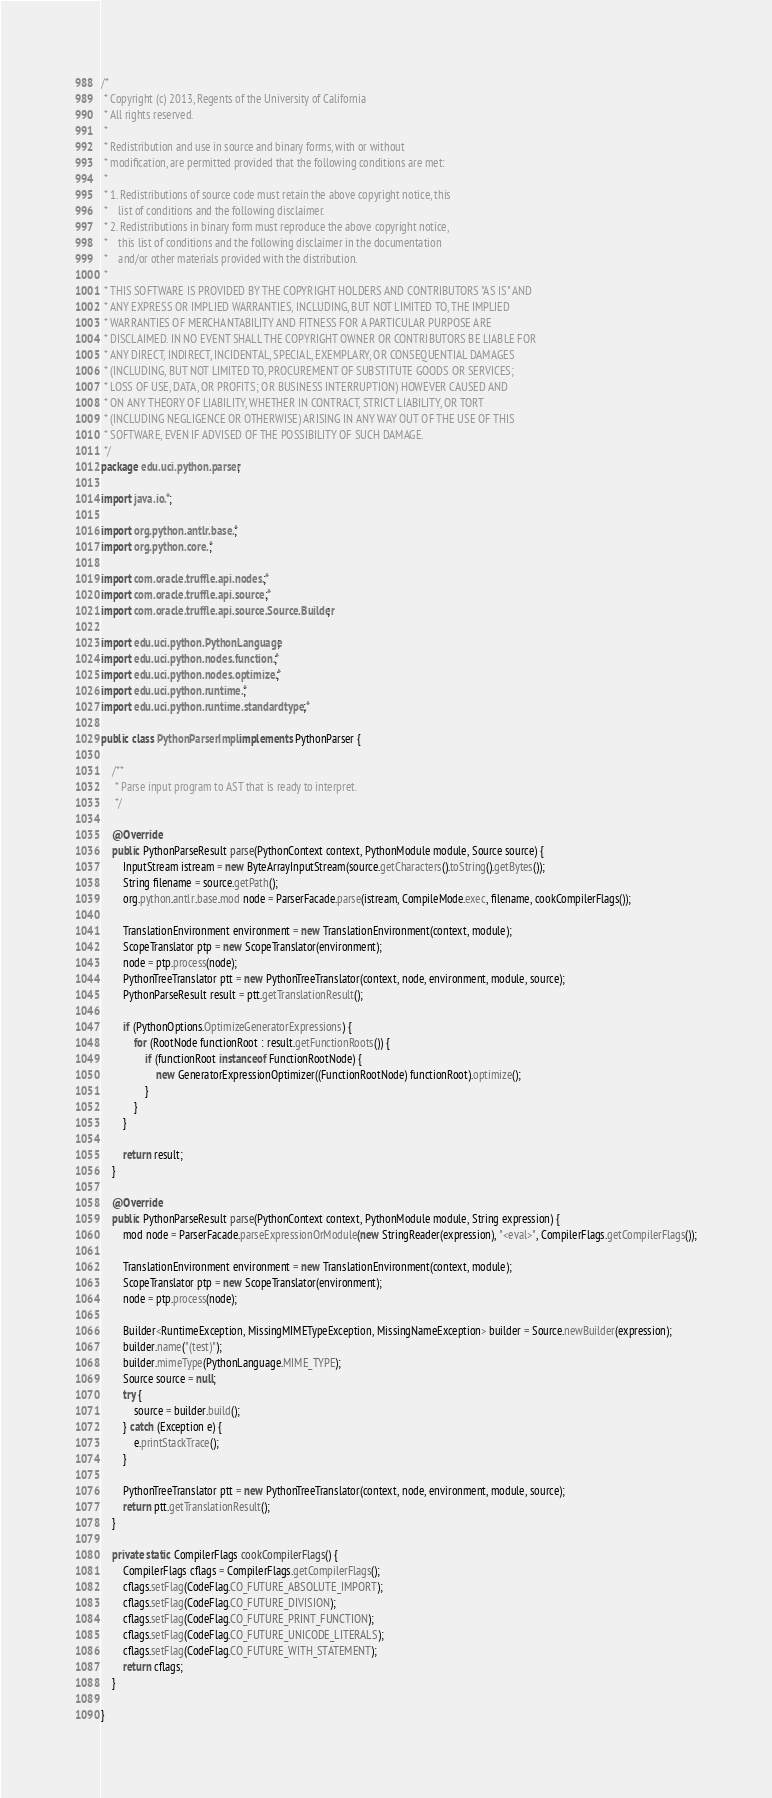<code> <loc_0><loc_0><loc_500><loc_500><_Java_>/*
 * Copyright (c) 2013, Regents of the University of California
 * All rights reserved.
 *
 * Redistribution and use in source and binary forms, with or without
 * modification, are permitted provided that the following conditions are met:
 *
 * 1. Redistributions of source code must retain the above copyright notice, this
 *    list of conditions and the following disclaimer.
 * 2. Redistributions in binary form must reproduce the above copyright notice,
 *    this list of conditions and the following disclaimer in the documentation
 *    and/or other materials provided with the distribution.
 *
 * THIS SOFTWARE IS PROVIDED BY THE COPYRIGHT HOLDERS AND CONTRIBUTORS "AS IS" AND
 * ANY EXPRESS OR IMPLIED WARRANTIES, INCLUDING, BUT NOT LIMITED TO, THE IMPLIED
 * WARRANTIES OF MERCHANTABILITY AND FITNESS FOR A PARTICULAR PURPOSE ARE
 * DISCLAIMED. IN NO EVENT SHALL THE COPYRIGHT OWNER OR CONTRIBUTORS BE LIABLE FOR
 * ANY DIRECT, INDIRECT, INCIDENTAL, SPECIAL, EXEMPLARY, OR CONSEQUENTIAL DAMAGES
 * (INCLUDING, BUT NOT LIMITED TO, PROCUREMENT OF SUBSTITUTE GOODS OR SERVICES;
 * LOSS OF USE, DATA, OR PROFITS; OR BUSINESS INTERRUPTION) HOWEVER CAUSED AND
 * ON ANY THEORY OF LIABILITY, WHETHER IN CONTRACT, STRICT LIABILITY, OR TORT
 * (INCLUDING NEGLIGENCE OR OTHERWISE) ARISING IN ANY WAY OUT OF THE USE OF THIS
 * SOFTWARE, EVEN IF ADVISED OF THE POSSIBILITY OF SUCH DAMAGE.
 */
package edu.uci.python.parser;

import java.io.*;

import org.python.antlr.base.*;
import org.python.core.*;

import com.oracle.truffle.api.nodes.*;
import com.oracle.truffle.api.source.*;
import com.oracle.truffle.api.source.Source.Builder;

import edu.uci.python.PythonLanguage;
import edu.uci.python.nodes.function.*;
import edu.uci.python.nodes.optimize.*;
import edu.uci.python.runtime.*;
import edu.uci.python.runtime.standardtype.*;

public class PythonParserImpl implements PythonParser {

    /**
     * Parse input program to AST that is ready to interpret.
     */

    @Override
    public PythonParseResult parse(PythonContext context, PythonModule module, Source source) {
        InputStream istream = new ByteArrayInputStream(source.getCharacters().toString().getBytes());
        String filename = source.getPath();
        org.python.antlr.base.mod node = ParserFacade.parse(istream, CompileMode.exec, filename, cookCompilerFlags());

        TranslationEnvironment environment = new TranslationEnvironment(context, module);
        ScopeTranslator ptp = new ScopeTranslator(environment);
        node = ptp.process(node);
        PythonTreeTranslator ptt = new PythonTreeTranslator(context, node, environment, module, source);
        PythonParseResult result = ptt.getTranslationResult();

        if (PythonOptions.OptimizeGeneratorExpressions) {
            for (RootNode functionRoot : result.getFunctionRoots()) {
                if (functionRoot instanceof FunctionRootNode) {
                    new GeneratorExpressionOptimizer((FunctionRootNode) functionRoot).optimize();
                }
            }
        }

        return result;
    }

    @Override
    public PythonParseResult parse(PythonContext context, PythonModule module, String expression) {
        mod node = ParserFacade.parseExpressionOrModule(new StringReader(expression), "<eval>", CompilerFlags.getCompilerFlags());

        TranslationEnvironment environment = new TranslationEnvironment(context, module);
        ScopeTranslator ptp = new ScopeTranslator(environment);
        node = ptp.process(node);

        Builder<RuntimeException, MissingMIMETypeException, MissingNameException> builder = Source.newBuilder(expression);
        builder.name("(test)");
        builder.mimeType(PythonLanguage.MIME_TYPE);
        Source source = null;
        try {
            source = builder.build();
        } catch (Exception e) {
            e.printStackTrace();
        }

        PythonTreeTranslator ptt = new PythonTreeTranslator(context, node, environment, module, source);
        return ptt.getTranslationResult();
    }

    private static CompilerFlags cookCompilerFlags() {
        CompilerFlags cflags = CompilerFlags.getCompilerFlags();
        cflags.setFlag(CodeFlag.CO_FUTURE_ABSOLUTE_IMPORT);
        cflags.setFlag(CodeFlag.CO_FUTURE_DIVISION);
        cflags.setFlag(CodeFlag.CO_FUTURE_PRINT_FUNCTION);
        cflags.setFlag(CodeFlag.CO_FUTURE_UNICODE_LITERALS);
        cflags.setFlag(CodeFlag.CO_FUTURE_WITH_STATEMENT);
        return cflags;
    }

}
</code> 